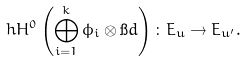Convert formula to latex. <formula><loc_0><loc_0><loc_500><loc_500>\ h H ^ { 0 } \left ( \bigoplus _ { i = 1 } ^ { k } \phi _ { i } \otimes \i d \right ) \colon E _ { u } \to E _ { u ^ { \prime } } .</formula> 